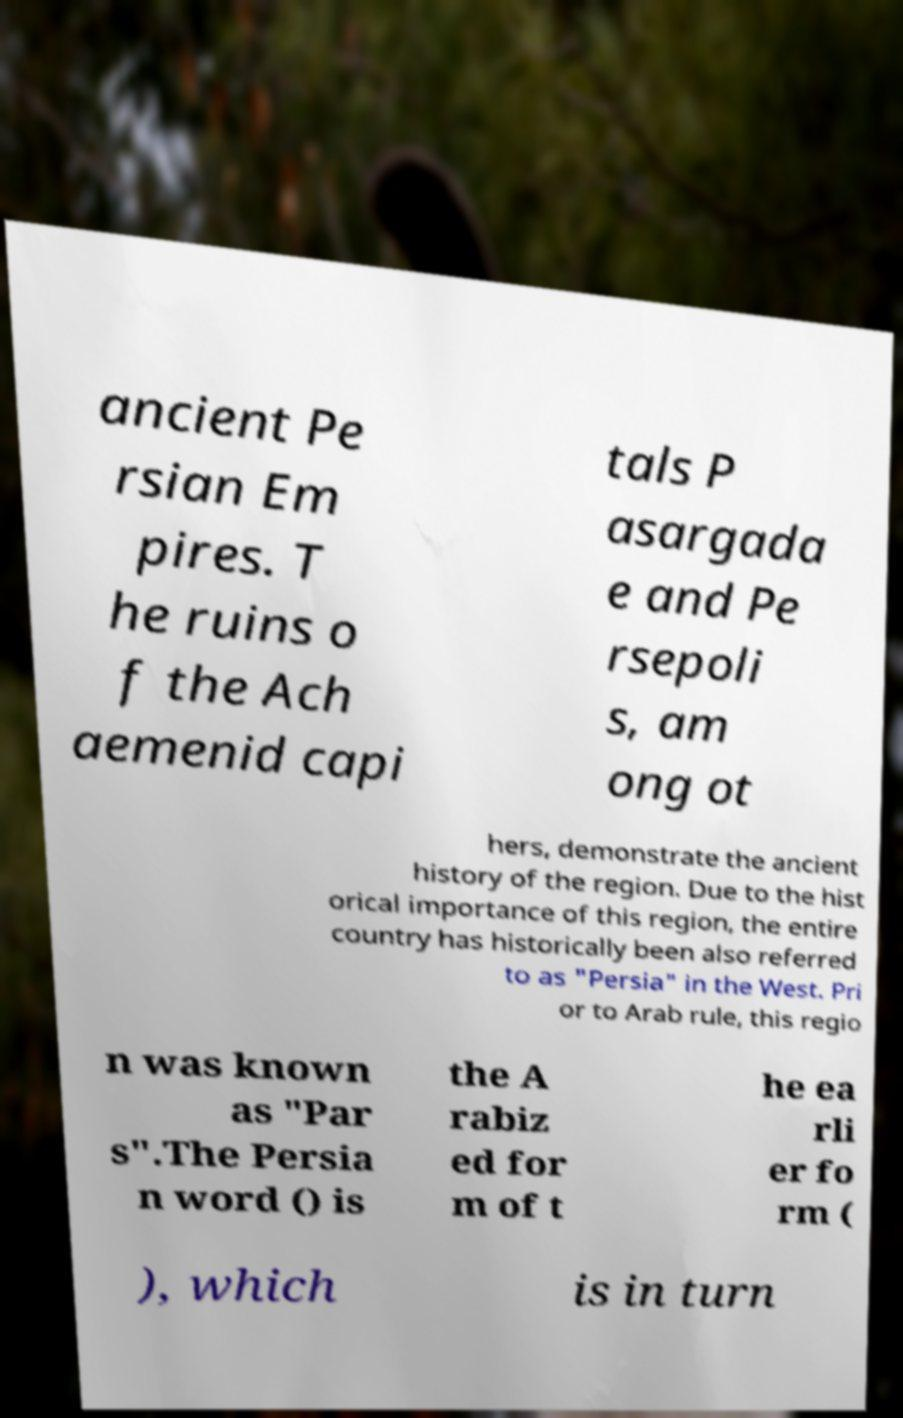Could you extract and type out the text from this image? ancient Pe rsian Em pires. T he ruins o f the Ach aemenid capi tals P asargada e and Pe rsepoli s, am ong ot hers, demonstrate the ancient history of the region. Due to the hist orical importance of this region, the entire country has historically been also referred to as "Persia" in the West. Pri or to Arab rule, this regio n was known as "Par s".The Persia n word () is the A rabiz ed for m of t he ea rli er fo rm ( ), which is in turn 